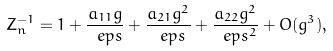Convert formula to latex. <formula><loc_0><loc_0><loc_500><loc_500>Z ^ { - 1 } _ { n } = 1 + \frac { a _ { 1 1 } g } { \ e p s } + \frac { a _ { 2 1 } g ^ { 2 } } { \ e p s } + \frac { a _ { 2 2 } g ^ { 2 } } { \ e p s ^ { 2 } } + O ( g ^ { 3 } ) ,</formula> 